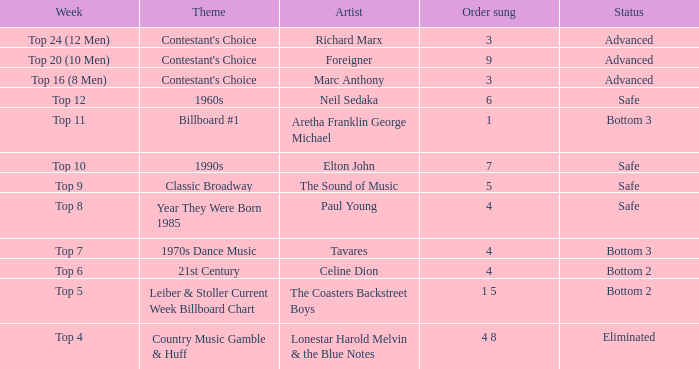What is the status when the artist is Neil Sedaka? Safe. 